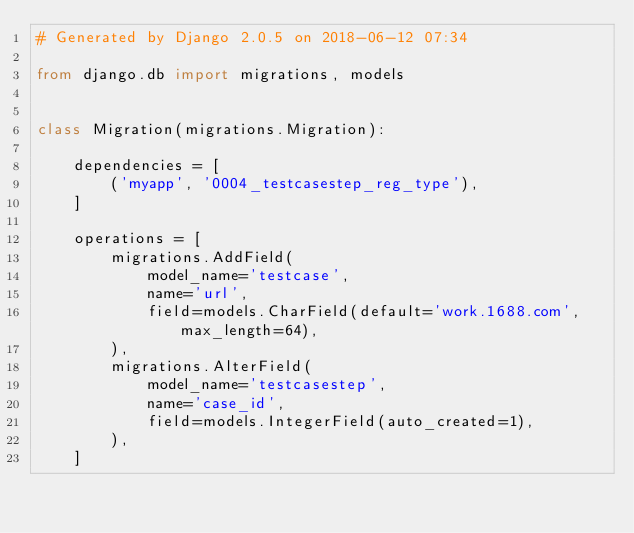Convert code to text. <code><loc_0><loc_0><loc_500><loc_500><_Python_># Generated by Django 2.0.5 on 2018-06-12 07:34

from django.db import migrations, models


class Migration(migrations.Migration):

    dependencies = [
        ('myapp', '0004_testcasestep_reg_type'),
    ]

    operations = [
        migrations.AddField(
            model_name='testcase',
            name='url',
            field=models.CharField(default='work.1688.com', max_length=64),
        ),
        migrations.AlterField(
            model_name='testcasestep',
            name='case_id',
            field=models.IntegerField(auto_created=1),
        ),
    ]
</code> 